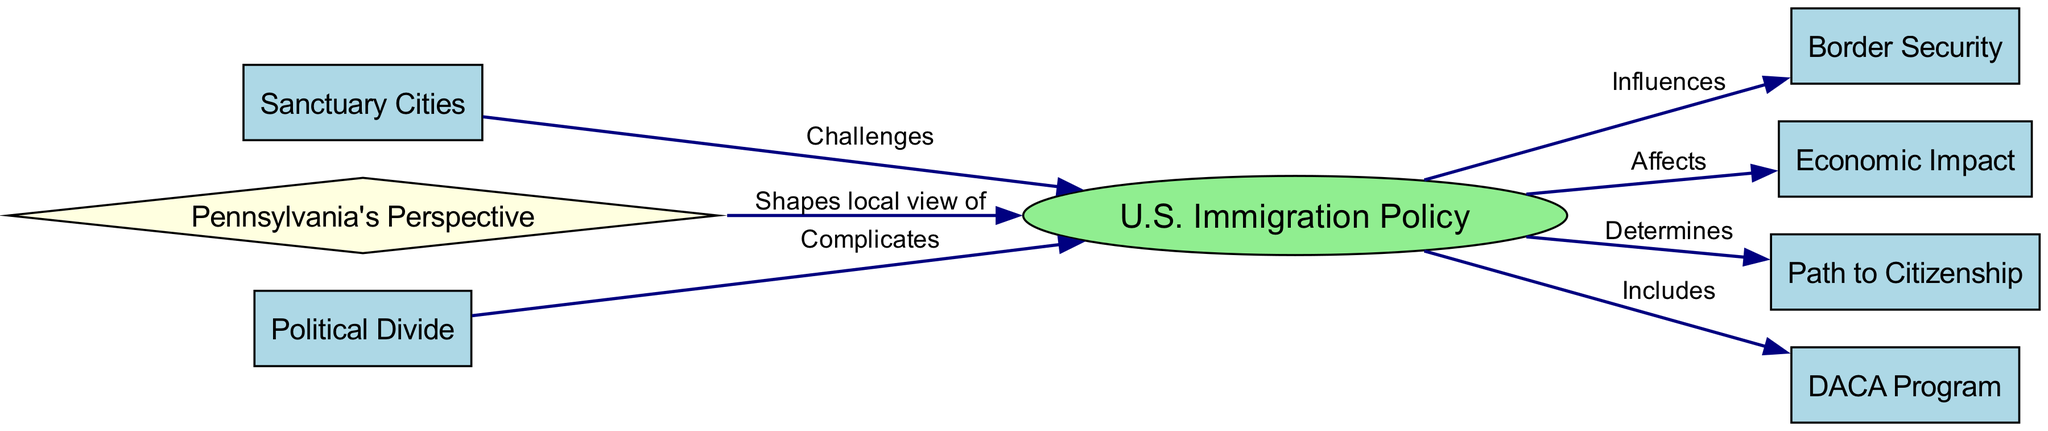What is at the center of the diagram? The center of the diagram features the node labeled "U.S. Immigration Policy" which serves as a central concept influencing various other nodes.
Answer: U.S. Immigration Policy How many nodes are present in the diagram? By counting the individual nodes, we find there are 8 nodes total within the diagram, each representing different aspects of immigration policy.
Answer: 8 What is one aspect that "U.S. Immigration Policy" directly affects? The edge between "U.S. Immigration Policy" and "Economic Impact" shows that immigration policy influences the economic implications, making it a direct effect.
Answer: Economic Impact Which node challenges the "U.S. Immigration Policy"? The edge connecting "Sanctuary Cities" to "U.S. Immigration Policy" indicates that sanctuary cities challenge immigration policies established at the federal level.
Answer: Sanctuary Cities What does "Pennsylvania's Perspective" do to "U.S. Immigration Policy"? The connection shows that Pennsylvania's Perspective shapes local views of U.S. Immigration Policy, indicating a regional influence on the overall framework.
Answer: Shapes local view of How does "Political Divide" relate to "U.S. Immigration Policy"? The arrow from "Political Divide" to "U.S. Immigration Policy" states that it complicates immigration policy discussions, highlighting how politics can lead to divergent viewpoints.
Answer: Complicates What type of relationship exists between "U.S. Immigration Policy" and "DACA Program"? The diagram indicates that the DACA Program is included as a component of U.S. Immigration Policy, making it an essential element under this broader category.
Answer: Includes What flows from "Path to Citizenship" as a result of "U.S. Immigration Policy"? The relationship signifies that U.S. Immigration Policy determines the Path to Citizenship, implying decisions about immigration directly influence citizenship processes.
Answer: Determines 